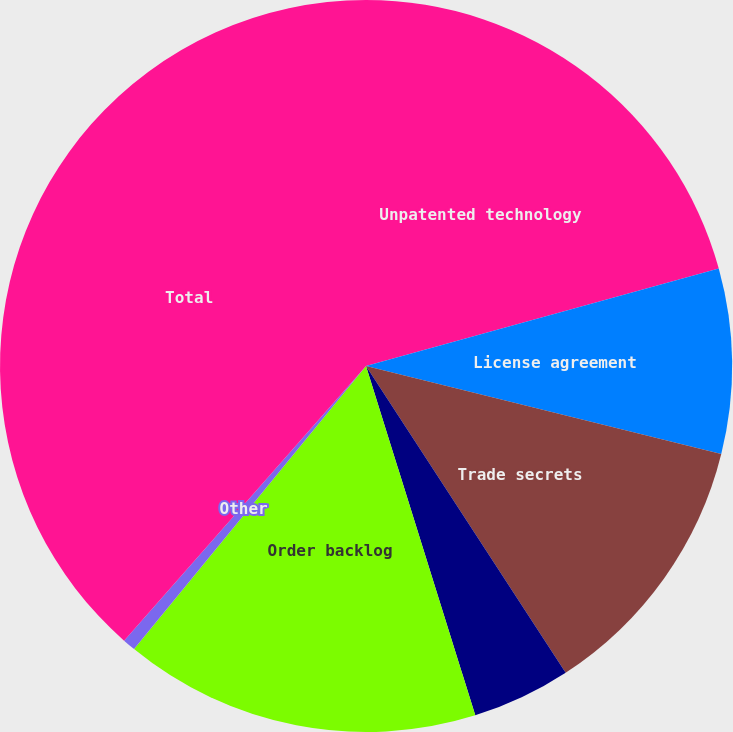Convert chart. <chart><loc_0><loc_0><loc_500><loc_500><pie_chart><fcel>Unpatented technology<fcel>License agreement<fcel>Trade secrets<fcel>Patented technology<fcel>Order backlog<fcel>Other<fcel>Total<nl><fcel>20.71%<fcel>8.16%<fcel>11.95%<fcel>4.36%<fcel>15.75%<fcel>0.57%<fcel>38.51%<nl></chart> 